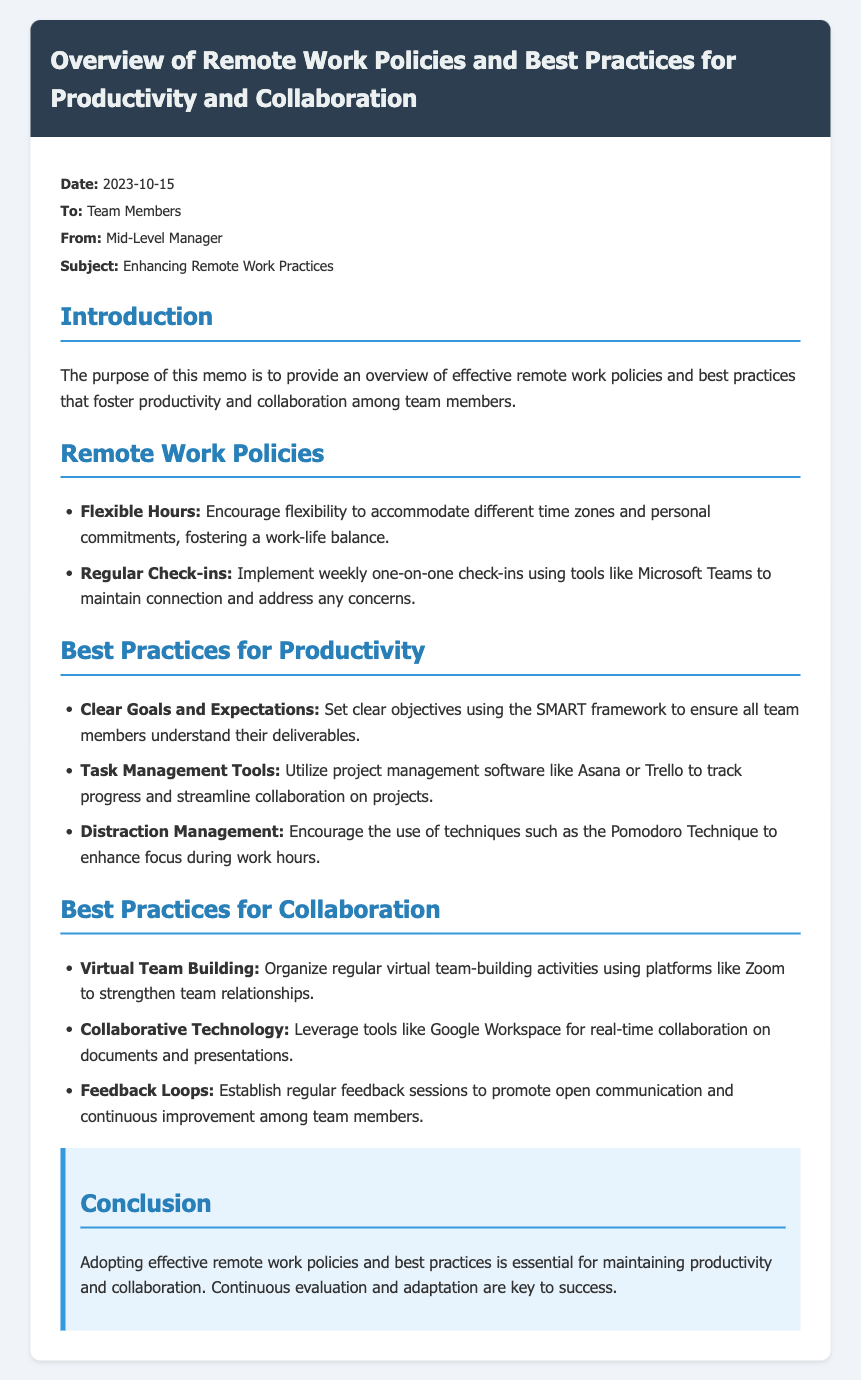what is the date of the memo? The date is specified in the memo, which is 2023-10-15.
Answer: 2023-10-15 who is the memo addressed to? The memo is directed towards the team members.
Answer: Team Members what flexible work policy is mentioned in the document? The memo lists encouraging flexibility to accommodate different time zones and personal commitments.
Answer: Flexible Hours what collaboration tool is suggested for virtual team building? The memo recommends using Zoom for organizing virtual team-building activities.
Answer: Zoom how often should regular check-ins be conducted according to the memo? The document states that weekly one-on-one check-ins should be implemented.
Answer: Weekly what technique is recommended for distraction management? The memo suggests the use of the Pomodoro Technique to enhance focus.
Answer: Pomodoro Technique what framework is used for setting clear goals? The memo specifies the SMART framework for setting objectives.
Answer: SMART how are feedback loops described in the document? Feedback loops are established through regular feedback sessions to promote communication.
Answer: Regular feedback sessions what is the main purpose of the memo? The purpose is to provide an overview of effective remote work policies for productivity and collaboration.
Answer: Overview of effective remote work policies 